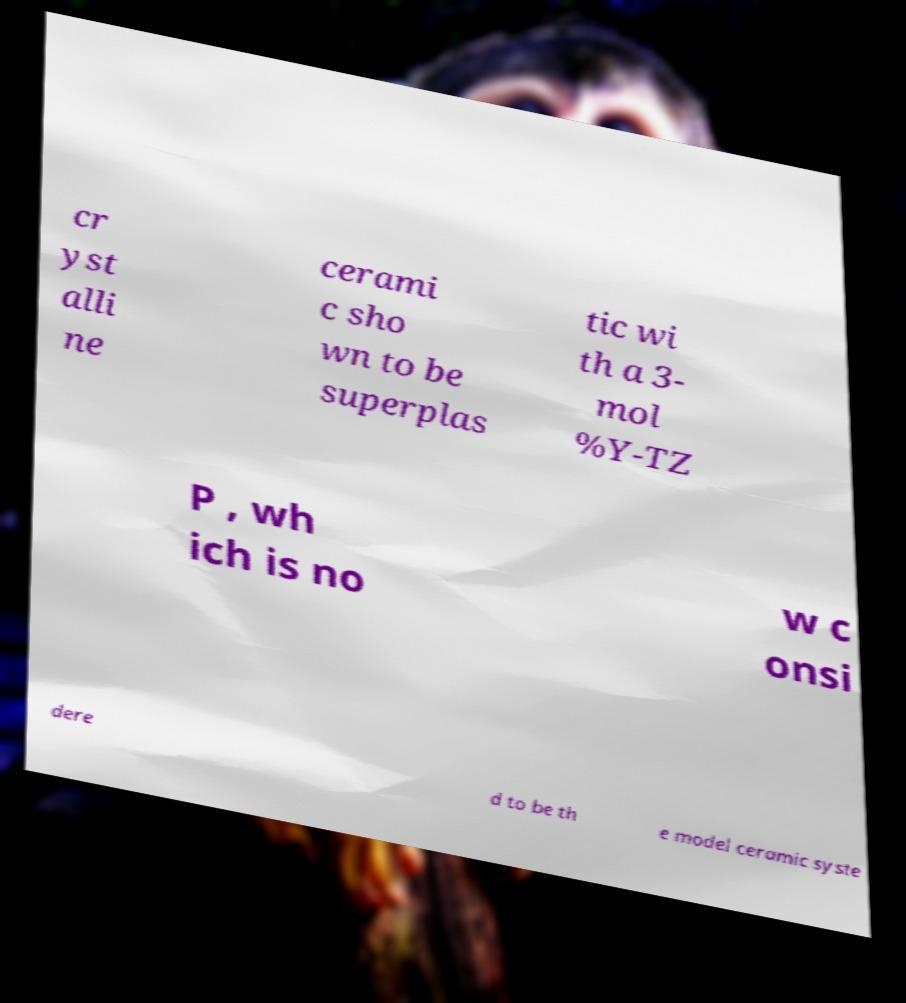I need the written content from this picture converted into text. Can you do that? cr yst alli ne cerami c sho wn to be superplas tic wi th a 3- mol %Y-TZ P , wh ich is no w c onsi dere d to be th e model ceramic syste 